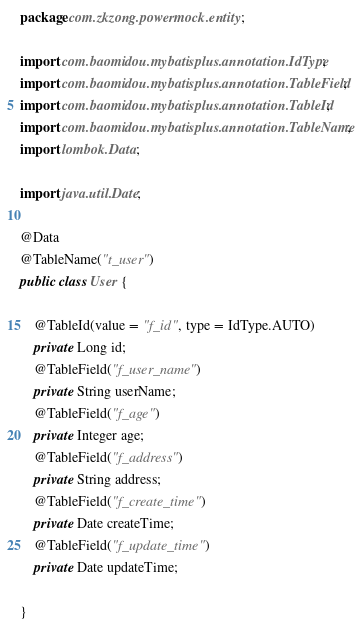<code> <loc_0><loc_0><loc_500><loc_500><_Java_>package com.zkzong.powermock.entity;

import com.baomidou.mybatisplus.annotation.IdType;
import com.baomidou.mybatisplus.annotation.TableField;
import com.baomidou.mybatisplus.annotation.TableId;
import com.baomidou.mybatisplus.annotation.TableName;
import lombok.Data;

import java.util.Date;

@Data
@TableName("t_user")
public class User {

    @TableId(value = "f_id", type = IdType.AUTO)
    private Long id;
    @TableField("f_user_name")
    private String userName;
    @TableField("f_age")
    private Integer age;
    @TableField("f_address")
    private String address;
    @TableField("f_create_time")
    private Date createTime;
    @TableField("f_update_time")
    private Date updateTime;

}
</code> 